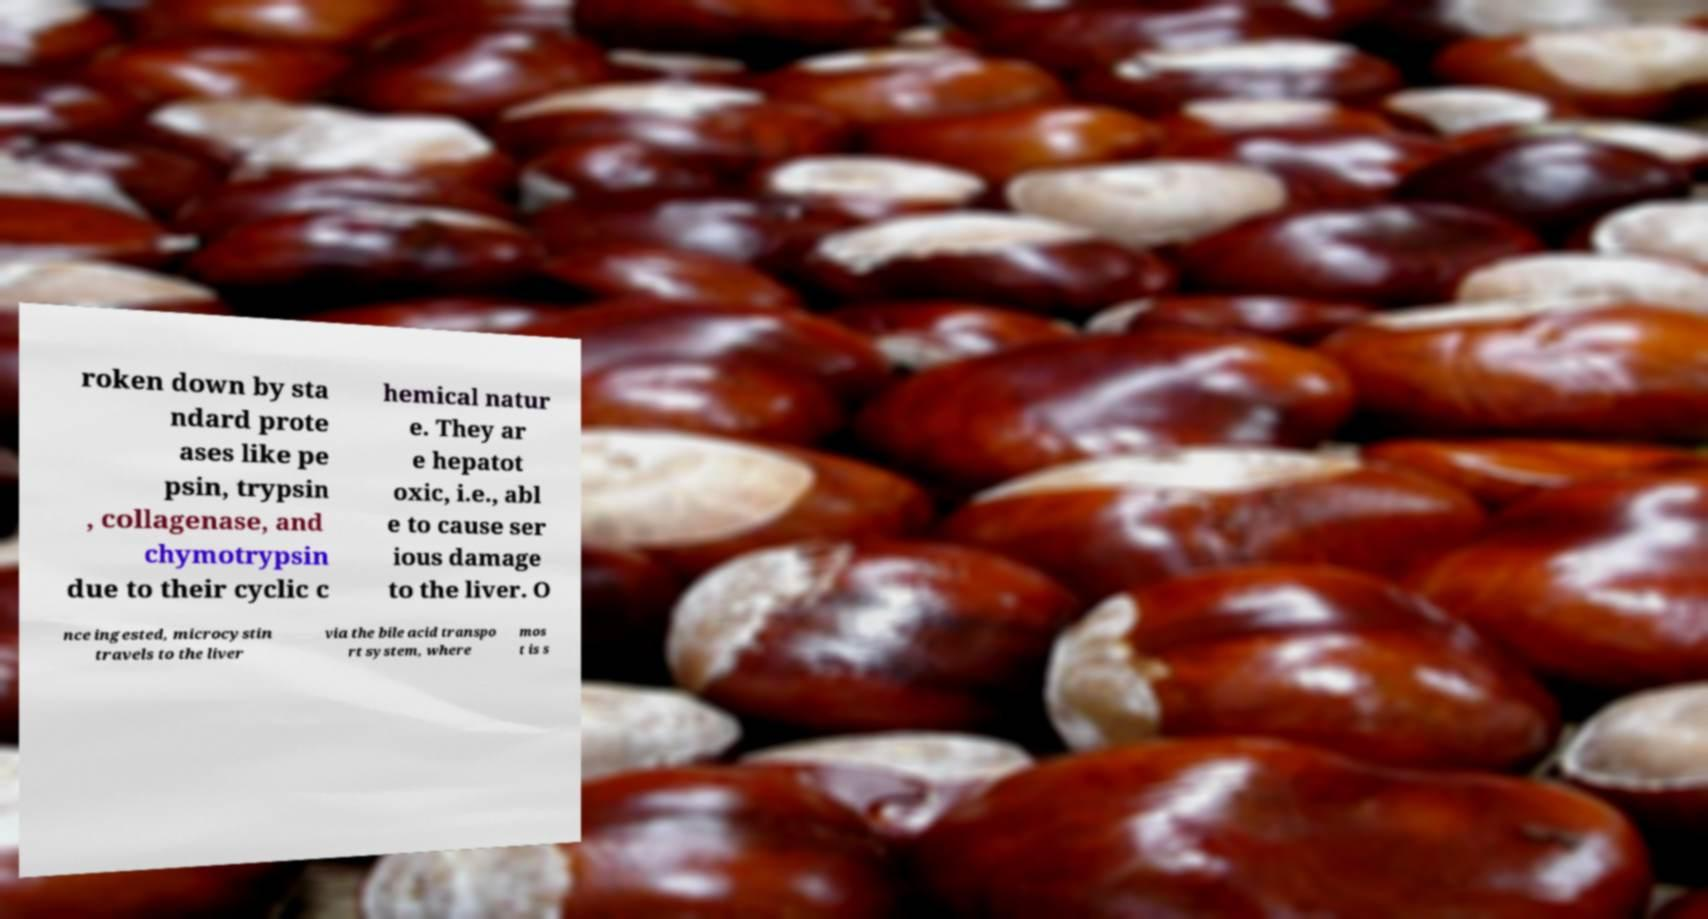What messages or text are displayed in this image? I need them in a readable, typed format. roken down by sta ndard prote ases like pe psin, trypsin , collagenase, and chymotrypsin due to their cyclic c hemical natur e. They ar e hepatot oxic, i.e., abl e to cause ser ious damage to the liver. O nce ingested, microcystin travels to the liver via the bile acid transpo rt system, where mos t is s 